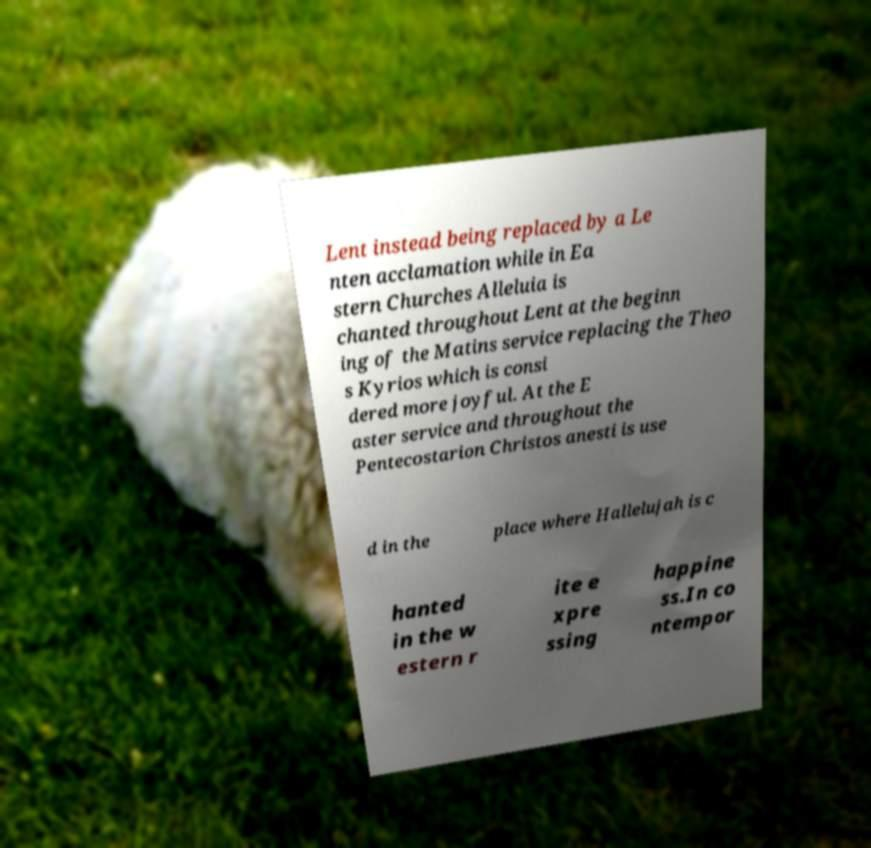Could you extract and type out the text from this image? Lent instead being replaced by a Le nten acclamation while in Ea stern Churches Alleluia is chanted throughout Lent at the beginn ing of the Matins service replacing the Theo s Kyrios which is consi dered more joyful. At the E aster service and throughout the Pentecostarion Christos anesti is use d in the place where Hallelujah is c hanted in the w estern r ite e xpre ssing happine ss.In co ntempor 